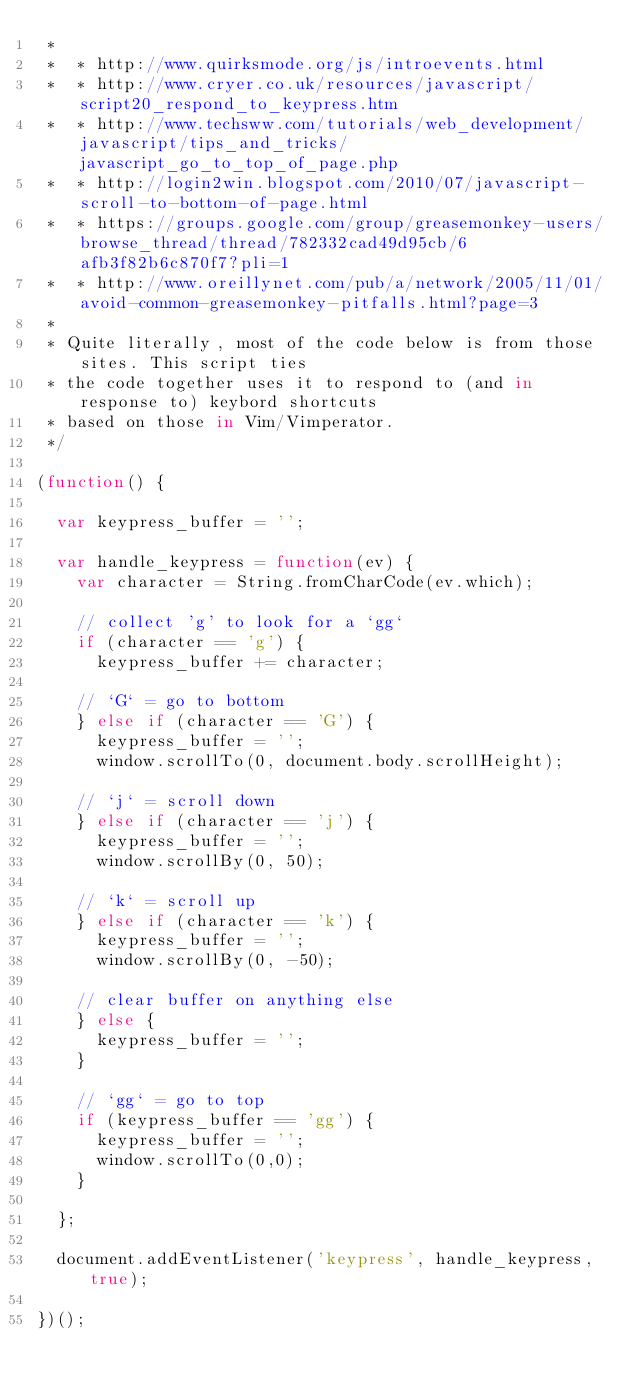<code> <loc_0><loc_0><loc_500><loc_500><_JavaScript_> *
 *  * http://www.quirksmode.org/js/introevents.html
 *  * http://www.cryer.co.uk/resources/javascript/script20_respond_to_keypress.htm
 *  * http://www.techsww.com/tutorials/web_development/javascript/tips_and_tricks/javascript_go_to_top_of_page.php
 *  * http://login2win.blogspot.com/2010/07/javascript-scroll-to-bottom-of-page.html
 *  * https://groups.google.com/group/greasemonkey-users/browse_thread/thread/782332cad49d95cb/6afb3f82b6c870f7?pli=1
 *  * http://www.oreillynet.com/pub/a/network/2005/11/01/avoid-common-greasemonkey-pitfalls.html?page=3
 *
 * Quite literally, most of the code below is from those sites. This script ties
 * the code together uses it to respond to (and in response to) keybord shortcuts
 * based on those in Vim/Vimperator.
 */

(function() {

  var keypress_buffer = '';

  var handle_keypress = function(ev) {
    var character = String.fromCharCode(ev.which);

    // collect 'g' to look for a `gg`
    if (character == 'g') {
      keypress_buffer += character;

    // `G` = go to bottom
    } else if (character == 'G') {
      keypress_buffer = '';
      window.scrollTo(0, document.body.scrollHeight);

    // `j` = scroll down
    } else if (character == 'j') {
      keypress_buffer = '';
      window.scrollBy(0, 50);

    // `k` = scroll up
    } else if (character == 'k') {
      keypress_buffer = '';
      window.scrollBy(0, -50);

    // clear buffer on anything else
    } else {
      keypress_buffer = '';
    }

    // `gg` = go to top
    if (keypress_buffer == 'gg') {
      keypress_buffer = '';
      window.scrollTo(0,0);
    }

  };

  document.addEventListener('keypress', handle_keypress, true);

})();

</code> 